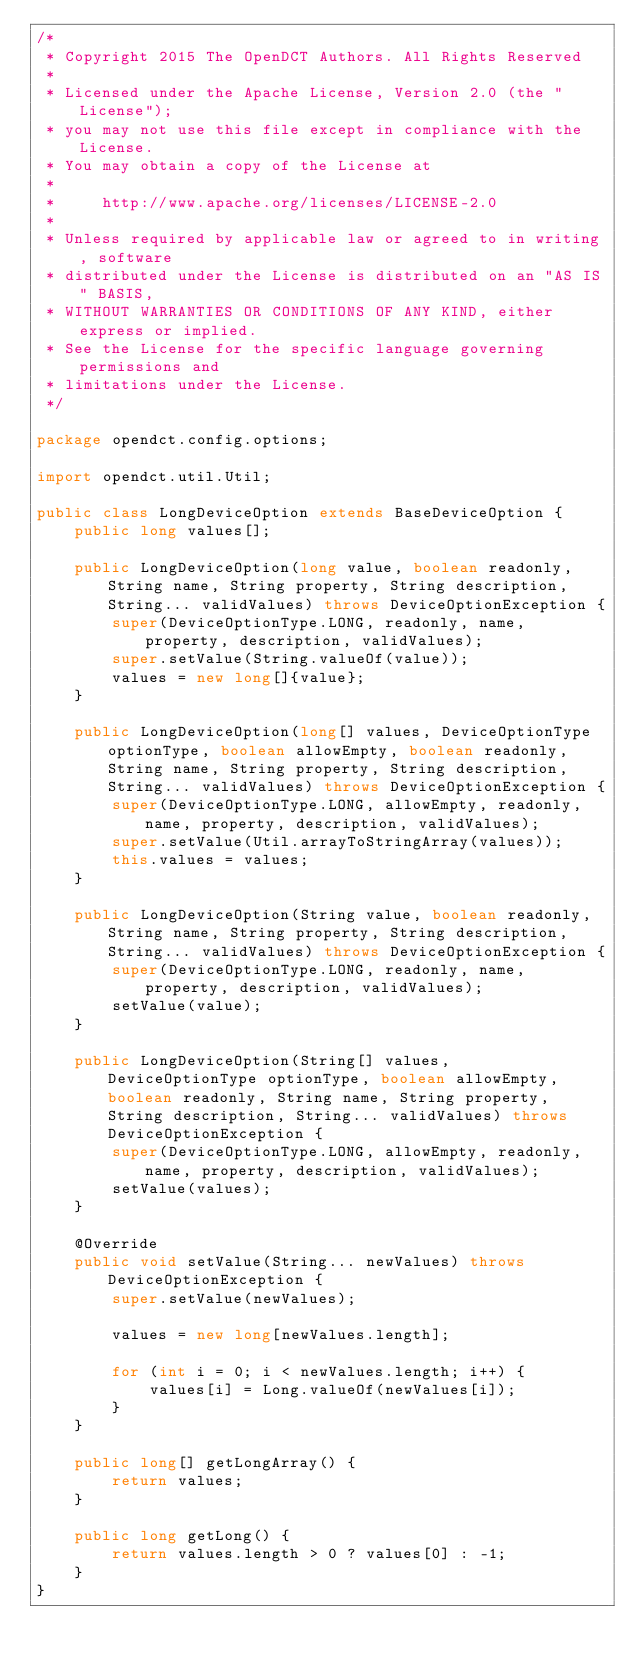<code> <loc_0><loc_0><loc_500><loc_500><_Java_>/*
 * Copyright 2015 The OpenDCT Authors. All Rights Reserved
 *
 * Licensed under the Apache License, Version 2.0 (the "License");
 * you may not use this file except in compliance with the License.
 * You may obtain a copy of the License at
 *
 *     http://www.apache.org/licenses/LICENSE-2.0
 *
 * Unless required by applicable law or agreed to in writing, software
 * distributed under the License is distributed on an "AS IS" BASIS,
 * WITHOUT WARRANTIES OR CONDITIONS OF ANY KIND, either express or implied.
 * See the License for the specific language governing permissions and
 * limitations under the License.
 */

package opendct.config.options;

import opendct.util.Util;

public class LongDeviceOption extends BaseDeviceOption {
    public long values[];

    public LongDeviceOption(long value, boolean readonly, String name, String property, String description, String... validValues) throws DeviceOptionException {
        super(DeviceOptionType.LONG, readonly, name, property, description, validValues);
        super.setValue(String.valueOf(value));
        values = new long[]{value};
    }

    public LongDeviceOption(long[] values, DeviceOptionType optionType, boolean allowEmpty, boolean readonly, String name, String property, String description, String... validValues) throws DeviceOptionException {
        super(DeviceOptionType.LONG, allowEmpty, readonly, name, property, description, validValues);
        super.setValue(Util.arrayToStringArray(values));
        this.values = values;
    }

    public LongDeviceOption(String value, boolean readonly, String name, String property, String description, String... validValues) throws DeviceOptionException {
        super(DeviceOptionType.LONG, readonly, name, property, description, validValues);
        setValue(value);
    }

    public LongDeviceOption(String[] values, DeviceOptionType optionType, boolean allowEmpty, boolean readonly, String name, String property, String description, String... validValues) throws DeviceOptionException {
        super(DeviceOptionType.LONG, allowEmpty, readonly, name, property, description, validValues);
        setValue(values);
    }

    @Override
    public void setValue(String... newValues) throws DeviceOptionException {
        super.setValue(newValues);

        values = new long[newValues.length];

        for (int i = 0; i < newValues.length; i++) {
            values[i] = Long.valueOf(newValues[i]);
        }
    }

    public long[] getLongArray() {
        return values;
    }

    public long getLong() {
        return values.length > 0 ? values[0] : -1;
    }
}
</code> 